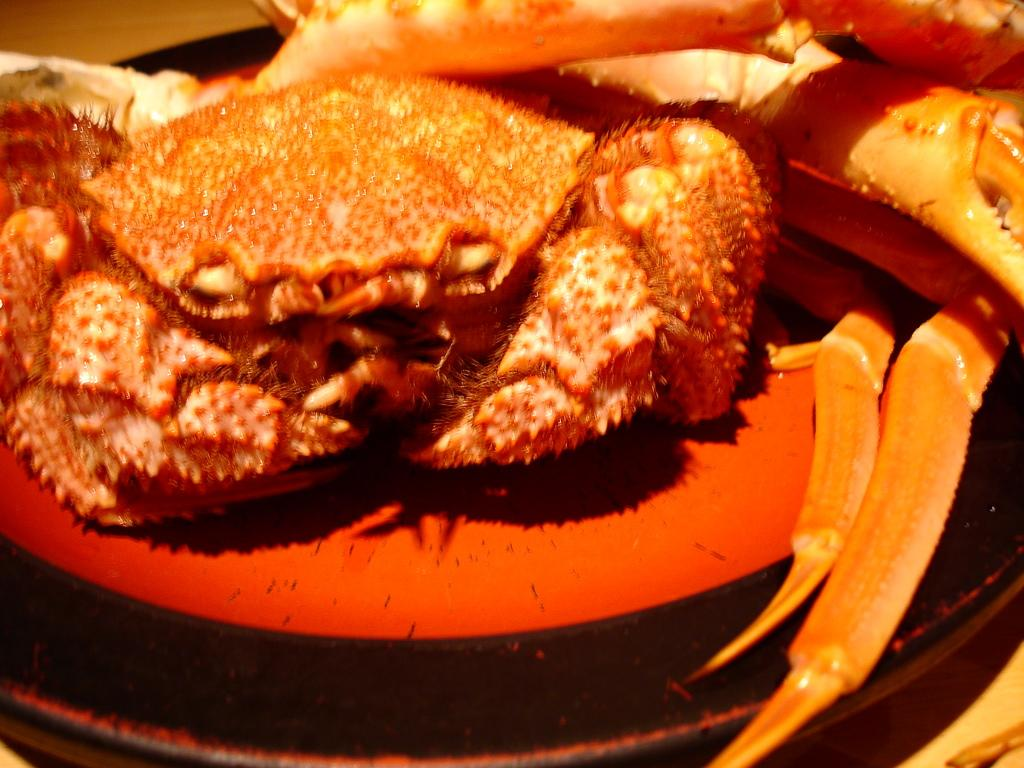What is on the plate that is visible in the image? There is a food item on a plate in the image. Where is the plate located in the image? The plate is on a table in the image. What statement can be made about the window in the image? There is no window present in the image; it only features a food item on a plate and a table. 